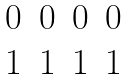<formula> <loc_0><loc_0><loc_500><loc_500>\begin{matrix} 0 & 0 & 0 & 0 \\ 1 & 1 & 1 & 1 \end{matrix}</formula> 